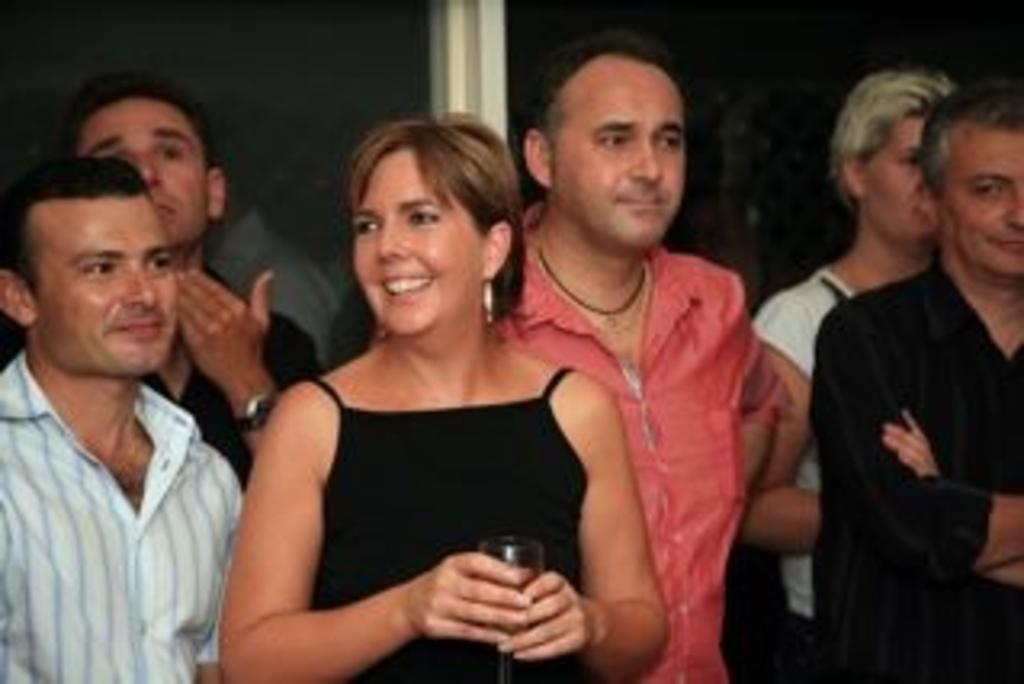What can be seen in the image? There is a group of people in the image. Can you describe the woman standing in the front of the group? The woman is standing in the front of the group and is holding a glass in her hand. What is the woman's facial expression? The woman is smiling. What type of skate is the woman using in the image? There is no skate present in the image; the woman is holding a glass and standing with a group of people. 